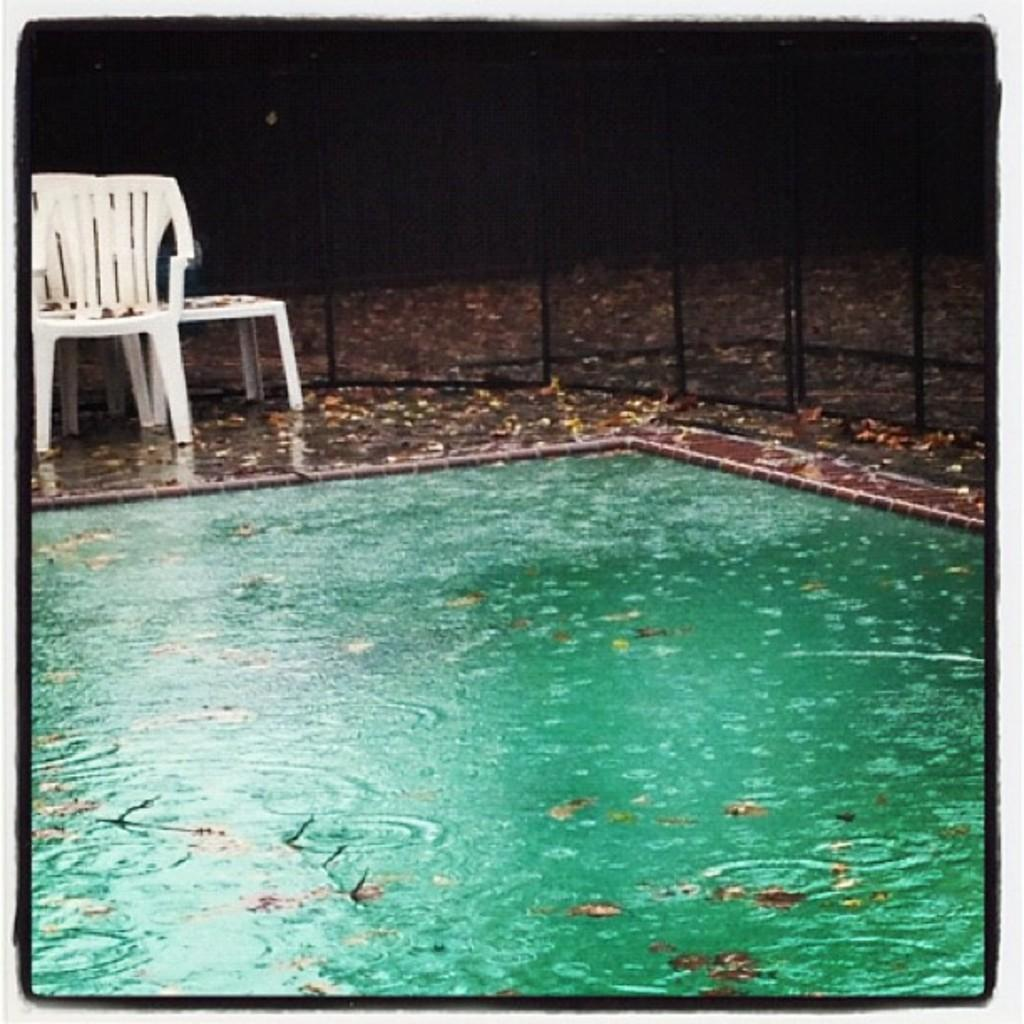What is the main feature in the image? There is a swimming pool in the image. What is present on the swimming pool? There are dry leaves on the swimming pool. What type of furniture can be seen in the image? There are chairs in the image. What can be seen in the background of the image? There is a net fence in the background of the image, and the background is dark. How many boats are visible in the image? There are no boats present in the image. What type of coat is hanging on the chair in the image? There is no coat present in the image; only chairs are visible. 